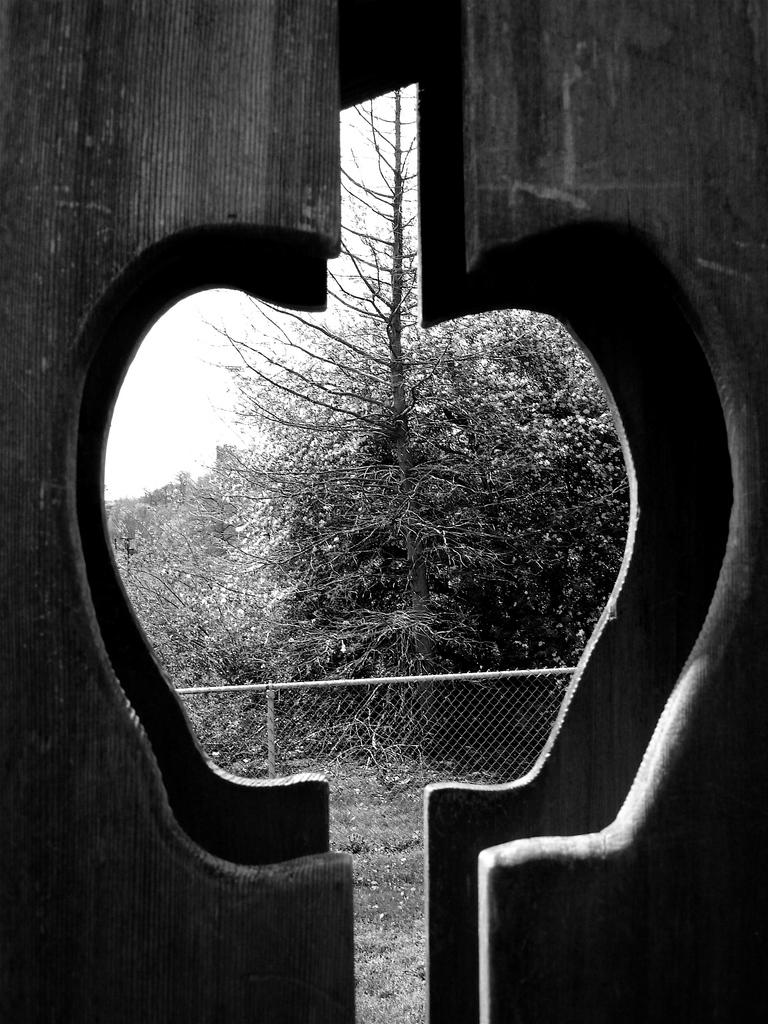What is the main subject of the image? The main subject of the image is a black and white picture of a window. What can be seen in the background of the image? In the background of the image, there is a fence, poles, a group of trees, and the sky. Can you describe the elements in the background of the image? The background of the image features a fence, poles, a group of trees, and the sky. How many coats are hanging on the poles in the image? There are no coats present in the image; the poles are in the background and are not associated with any coats. 